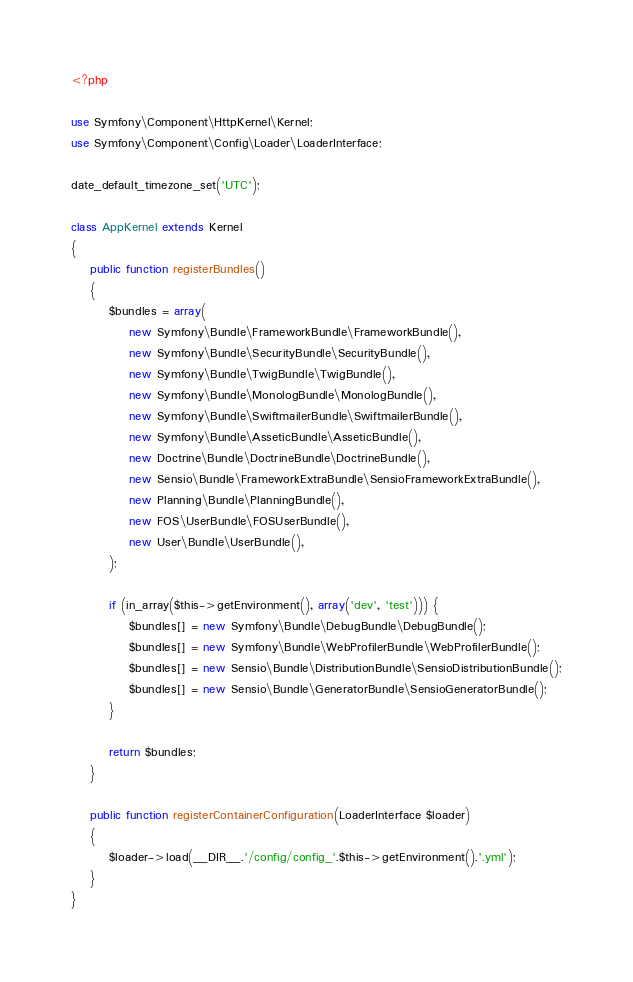Convert code to text. <code><loc_0><loc_0><loc_500><loc_500><_PHP_><?php

use Symfony\Component\HttpKernel\Kernel;
use Symfony\Component\Config\Loader\LoaderInterface;

date_default_timezone_set('UTC');

class AppKernel extends Kernel
{
    public function registerBundles()
    {
        $bundles = array(
            new Symfony\Bundle\FrameworkBundle\FrameworkBundle(),
            new Symfony\Bundle\SecurityBundle\SecurityBundle(),
            new Symfony\Bundle\TwigBundle\TwigBundle(),
            new Symfony\Bundle\MonologBundle\MonologBundle(),
            new Symfony\Bundle\SwiftmailerBundle\SwiftmailerBundle(),
            new Symfony\Bundle\AsseticBundle\AsseticBundle(),
            new Doctrine\Bundle\DoctrineBundle\DoctrineBundle(),
            new Sensio\Bundle\FrameworkExtraBundle\SensioFrameworkExtraBundle(),
            new Planning\Bundle\PlanningBundle(),
            new FOS\UserBundle\FOSUserBundle(),
            new User\Bundle\UserBundle(),
        );

        if (in_array($this->getEnvironment(), array('dev', 'test'))) {
            $bundles[] = new Symfony\Bundle\DebugBundle\DebugBundle();
            $bundles[] = new Symfony\Bundle\WebProfilerBundle\WebProfilerBundle();
            $bundles[] = new Sensio\Bundle\DistributionBundle\SensioDistributionBundle();
            $bundles[] = new Sensio\Bundle\GeneratorBundle\SensioGeneratorBundle();
        }

        return $bundles;
    }

    public function registerContainerConfiguration(LoaderInterface $loader)
    {
        $loader->load(__DIR__.'/config/config_'.$this->getEnvironment().'.yml');
    }
}
</code> 